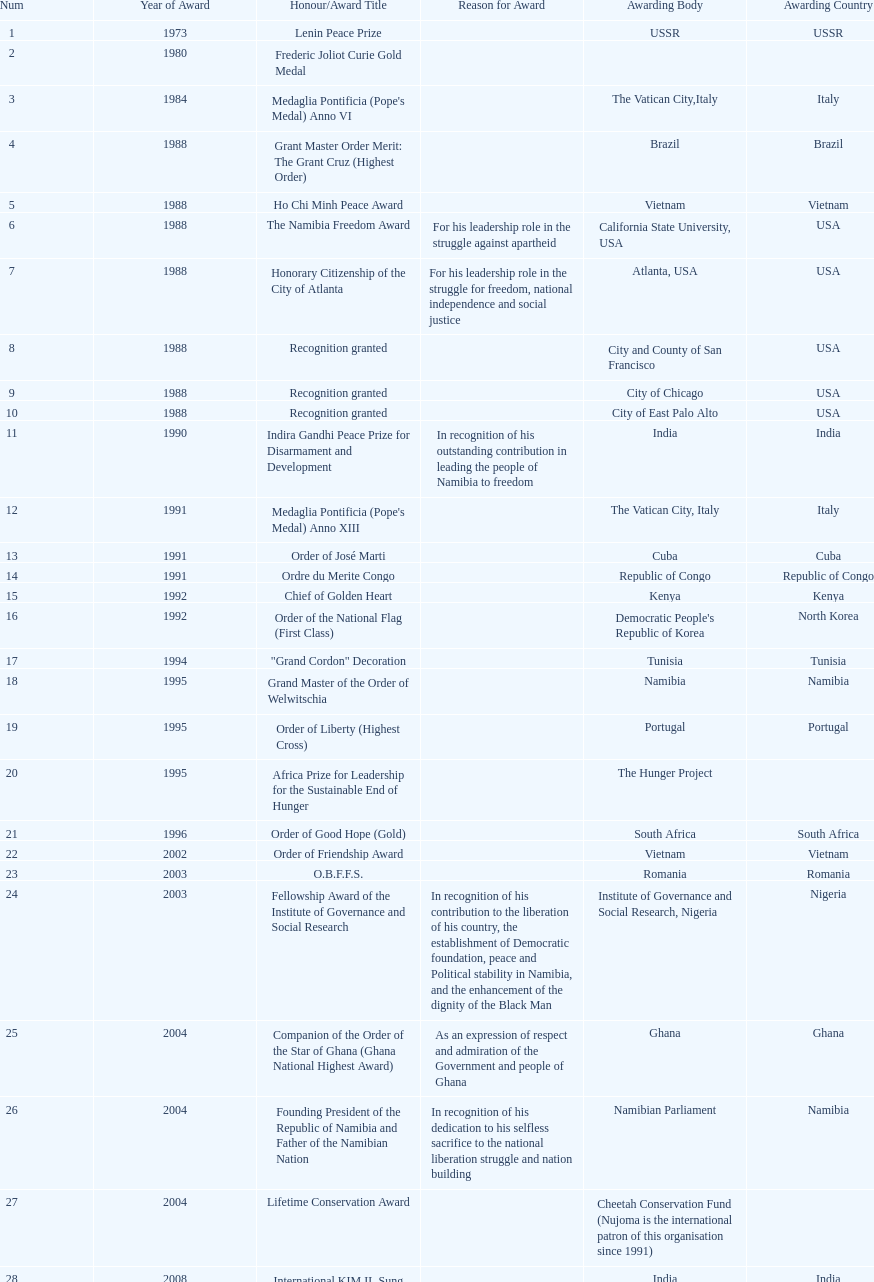The "fellowship award of the institute of governance and social research" was awarded in 2003 or 2004? 2003. Write the full table. {'header': ['Num', 'Year of Award', 'Honour/Award Title', 'Reason for Award', 'Awarding Body', 'Awarding Country'], 'rows': [['1', '1973', 'Lenin Peace Prize', '', 'USSR', 'USSR'], ['2', '1980', 'Frederic Joliot Curie Gold Medal', '', '', ''], ['3', '1984', "Medaglia Pontificia (Pope's Medal) Anno VI", '', 'The Vatican City,Italy', 'Italy'], ['4', '1988', 'Grant Master Order Merit: The Grant Cruz (Highest Order)', '', 'Brazil', 'Brazil'], ['5', '1988', 'Ho Chi Minh Peace Award', '', 'Vietnam', 'Vietnam'], ['6', '1988', 'The Namibia Freedom Award', 'For his leadership role in the struggle against apartheid', 'California State University, USA', 'USA'], ['7', '1988', 'Honorary Citizenship of the City of Atlanta', 'For his leadership role in the struggle for freedom, national independence and social justice', 'Atlanta, USA', 'USA'], ['8', '1988', 'Recognition granted', '', 'City and County of San Francisco', 'USA'], ['9', '1988', 'Recognition granted', '', 'City of Chicago', 'USA'], ['10', '1988', 'Recognition granted', '', 'City of East Palo Alto', 'USA'], ['11', '1990', 'Indira Gandhi Peace Prize for Disarmament and Development', 'In recognition of his outstanding contribution in leading the people of Namibia to freedom', 'India', 'India'], ['12', '1991', "Medaglia Pontificia (Pope's Medal) Anno XIII", '', 'The Vatican City, Italy', 'Italy'], ['13', '1991', 'Order of José Marti', '', 'Cuba', 'Cuba'], ['14', '1991', 'Ordre du Merite Congo', '', 'Republic of Congo', 'Republic of Congo'], ['15', '1992', 'Chief of Golden Heart', '', 'Kenya', 'Kenya'], ['16', '1992', 'Order of the National Flag (First Class)', '', "Democratic People's Republic of Korea", 'North Korea'], ['17', '1994', '"Grand Cordon" Decoration', '', 'Tunisia', 'Tunisia'], ['18', '1995', 'Grand Master of the Order of Welwitschia', '', 'Namibia', 'Namibia'], ['19', '1995', 'Order of Liberty (Highest Cross)', '', 'Portugal', 'Portugal'], ['20', '1995', 'Africa Prize for Leadership for the Sustainable End of Hunger', '', 'The Hunger Project', ''], ['21', '1996', 'Order of Good Hope (Gold)', '', 'South Africa', 'South Africa'], ['22', '2002', 'Order of Friendship Award', '', 'Vietnam', 'Vietnam'], ['23', '2003', 'O.B.F.F.S.', '', 'Romania', 'Romania'], ['24', '2003', 'Fellowship Award of the Institute of Governance and Social Research', 'In recognition of his contribution to the liberation of his country, the establishment of Democratic foundation, peace and Political stability in Namibia, and the enhancement of the dignity of the Black Man', 'Institute of Governance and Social Research, Nigeria', 'Nigeria'], ['25', '2004', 'Companion of the Order of the Star of Ghana (Ghana National Highest Award)', 'As an expression of respect and admiration of the Government and people of Ghana', 'Ghana', 'Ghana'], ['26', '2004', 'Founding President of the Republic of Namibia and Father of the Namibian Nation', 'In recognition of his dedication to his selfless sacrifice to the national liberation struggle and nation building', 'Namibian Parliament', 'Namibia'], ['27', '2004', 'Lifetime Conservation Award', '', 'Cheetah Conservation Fund (Nujoma is the international patron of this organisation since 1991)', ''], ['28', '2008', 'International KIM IL Sung Prize Certificate', '', 'India', 'India'], ['29', '2010', 'Sir Seretse Khama SADC Meda', '', 'SADC', '']]} 